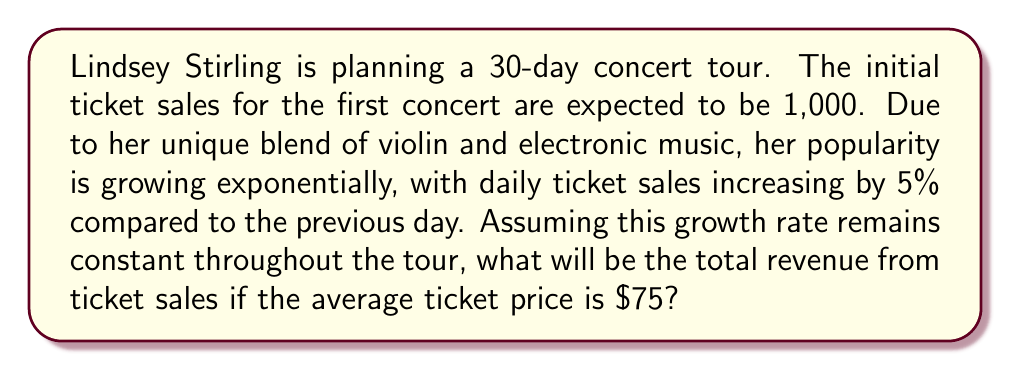What is the answer to this math problem? Let's approach this problem step-by-step using an exponential growth model:

1) First, we need to find the number of tickets sold for each day of the tour.
   Let $T_n$ be the number of tickets sold on day $n$.
   
   $T_1 = 1000$ (initial tickets)
   $T_n = 1000 * (1.05)^{n-1}$ for $n = 1, 2, ..., 30$

2) To find the total number of tickets sold over the 30-day tour, we need to sum this sequence:

   $\text{Total Tickets} = \sum_{n=1}^{30} 1000 * (1.05)^{n-1}$

3) This is a geometric series with:
   $a = 1000$ (first term)
   $r = 1.05$ (common ratio)
   $n = 30$ (number of terms)

4) The sum of a geometric series is given by the formula:
   $S_n = a\frac{1-r^n}{1-r}$ where $r \neq 1$

5) Plugging in our values:

   $\text{Total Tickets} = 1000 * \frac{1-(1.05)^{30}}{1-1.05}$
                         $= 1000 * \frac{1-(1.05)^{30}}{-0.05}$
                         $= 1000 * \frac{(1.05)^{30}-1}{0.05}$
                         $\approx 66,438.85$

6) To get the total revenue, we multiply by the average ticket price:

   $\text{Total Revenue} = 66,438.85 * $75 = $4,982,913.75$
Answer: $4,982,913.75 